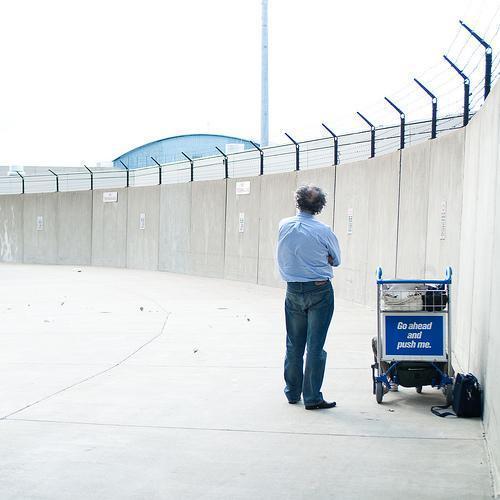How many people are in the picture?
Give a very brief answer. 1. 